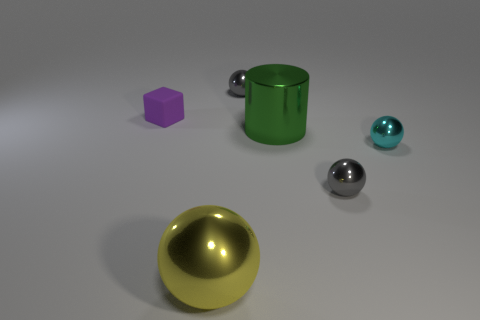What is the color of the matte thing that is the same size as the cyan ball?
Provide a short and direct response. Purple. Do the block and the metallic cylinder have the same size?
Your answer should be compact. No. There is a metallic thing that is behind the small cyan object and in front of the rubber block; how big is it?
Offer a terse response. Large. What number of rubber objects are either small purple spheres or tiny cubes?
Provide a short and direct response. 1. Are there more big green cylinders that are in front of the cyan sphere than purple cubes?
Your answer should be very brief. No. There is a tiny thing that is on the left side of the yellow ball; what material is it?
Make the answer very short. Rubber. What number of small gray things are the same material as the big green cylinder?
Give a very brief answer. 2. The metal thing that is on the left side of the big green metal object and in front of the small matte block has what shape?
Provide a short and direct response. Sphere. How many objects are big metal objects behind the big yellow metal ball or tiny gray things that are behind the rubber object?
Make the answer very short. 2. Are there an equal number of gray objects in front of the large cylinder and big green cylinders that are in front of the small cyan metal object?
Offer a terse response. No. 